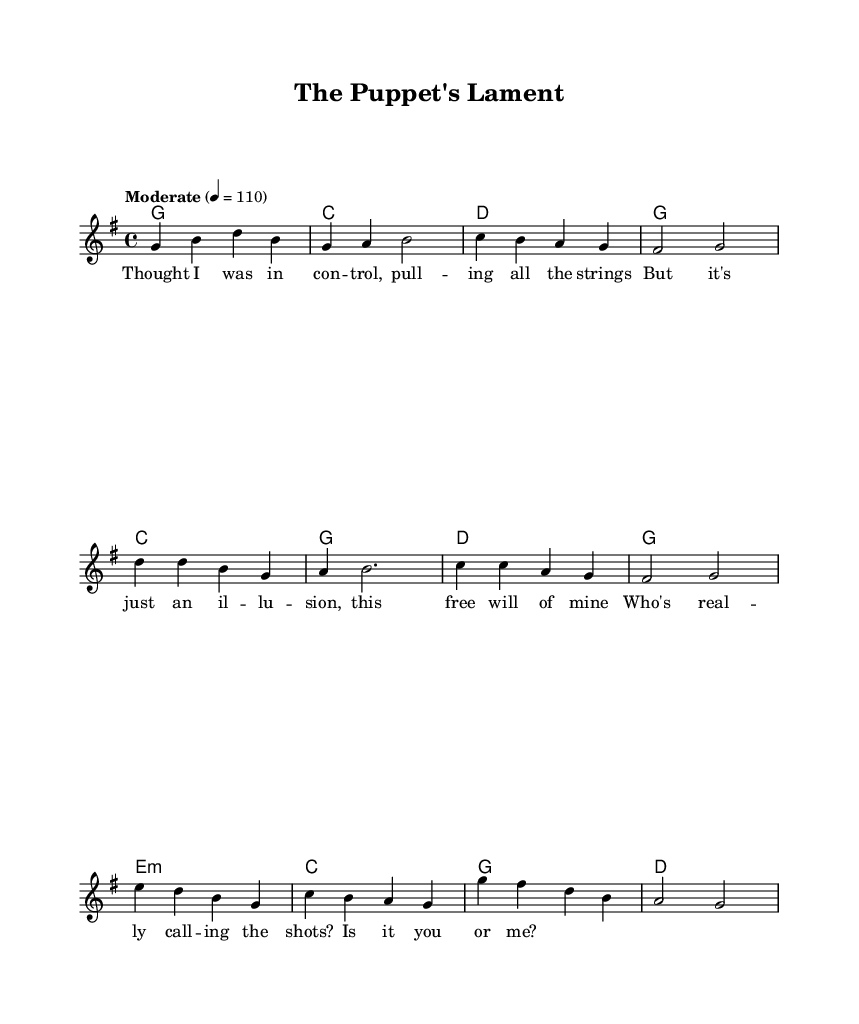What is the key signature of this music? The key signature is G major, which has one sharp (F#). This can be identified by looking at the key signature at the beginning of the staff.
Answer: G major What is the time signature of this music? The time signature is 4/4, which is indicated at the beginning of the score. This means there are four beats per measure and a quarter note gets one beat.
Answer: 4/4 What is the tempo marking for this piece? The tempo marking is "Moderate," which suggests a moderate speed for performance. It is set to 110 beats per minute, noted beside the tempo indication.
Answer: Moderate How many measures are in the verse section? The verse consists of four measures, which is determined by counting the number of repeats for the melody section labeled as verse.
Answer: 4 What is the chord progression for the chorus? The chord progression for the chorus is C - G - D - G. This is obtained by looking at the harmonic structure specifically for the chorus section of the sheet music.
Answer: C - G - D - G What is the lyrical theme of the bridge? The lyrical theme of the bridge reflects on questioning who has control, as indicated by the lyrics "Who's really calling the shots? Is it you or me?" This contains elements of introspection related to conscious will.
Answer: Questioning control 